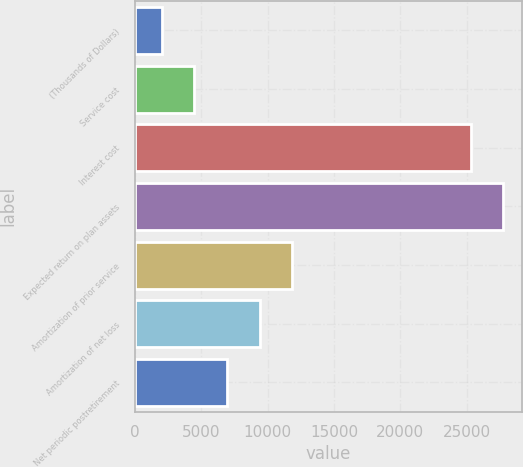<chart> <loc_0><loc_0><loc_500><loc_500><bar_chart><fcel>(Thousands of Dollars)<fcel>Service cost<fcel>Interest cost<fcel>Expected return on plan assets<fcel>Amortization of prior service<fcel>Amortization of net loss<fcel>Net periodic postretirement<nl><fcel>2015<fcel>4473.5<fcel>25297<fcel>27755.5<fcel>11849<fcel>9390.5<fcel>6932<nl></chart> 